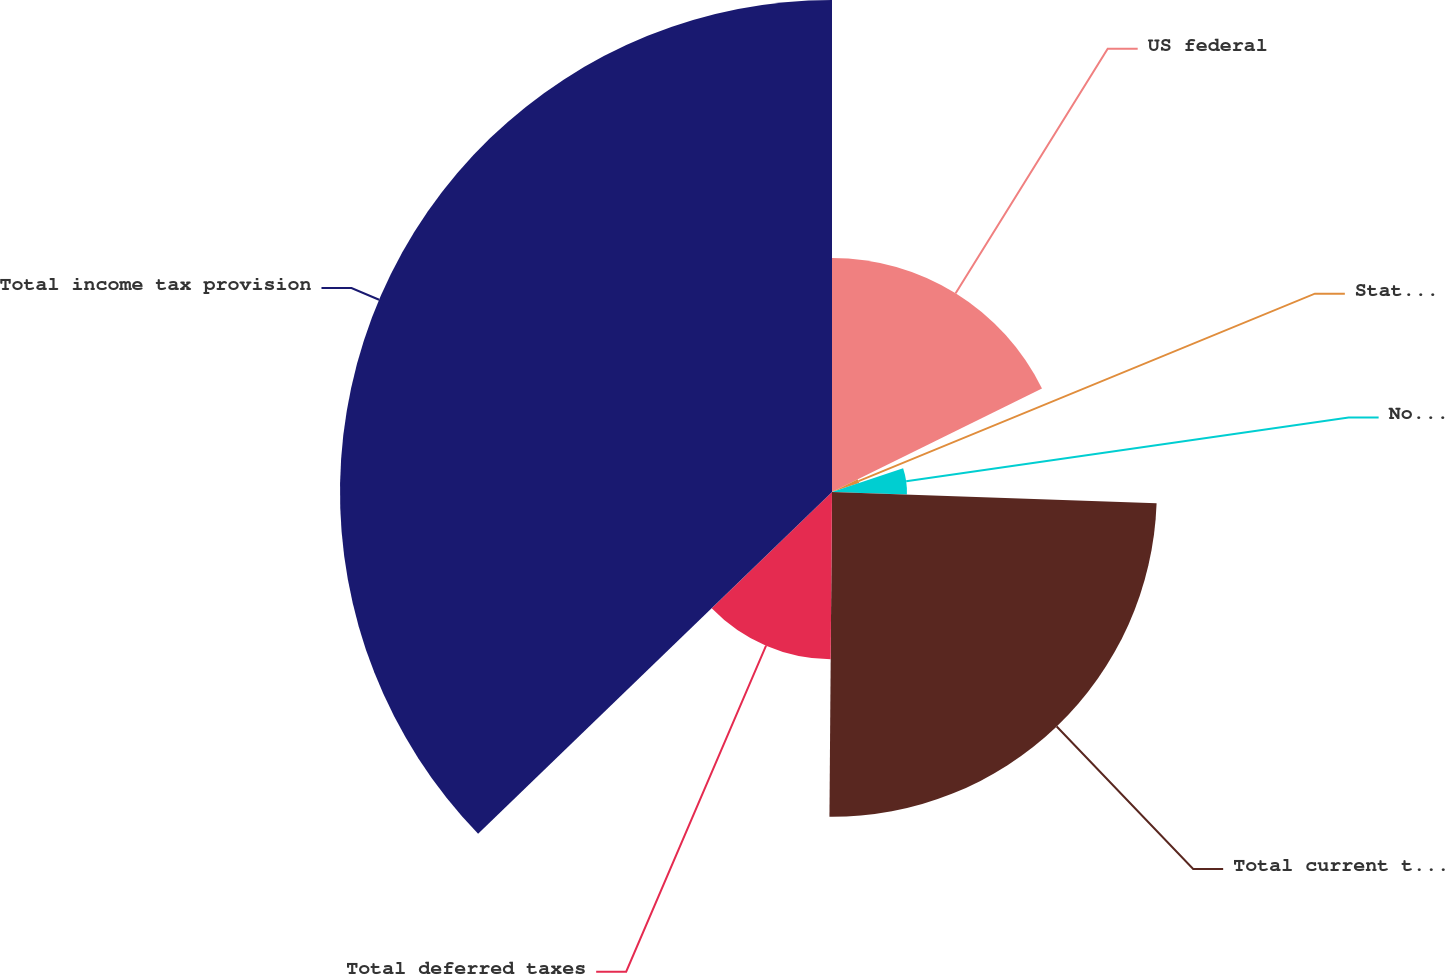<chart> <loc_0><loc_0><loc_500><loc_500><pie_chart><fcel>US federal<fcel>State and local<fcel>Non-US<fcel>Total current taxes<fcel>Total deferred taxes<fcel>Total income tax provision<nl><fcel>17.71%<fcel>2.17%<fcel>5.67%<fcel>24.57%<fcel>12.65%<fcel>37.22%<nl></chart> 